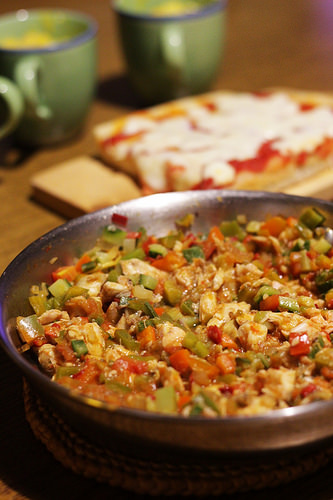<image>
Can you confirm if the food is in the skillet? Yes. The food is contained within or inside the skillet, showing a containment relationship. Is there a mug on the mug? No. The mug is not positioned on the mug. They may be near each other, but the mug is not supported by or resting on top of the mug. Is there a food in front of the cub? No. The food is not in front of the cub. The spatial positioning shows a different relationship between these objects. 